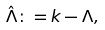<formula> <loc_0><loc_0><loc_500><loc_500>\hat { \Lambda } \colon = k - \Lambda ,</formula> 